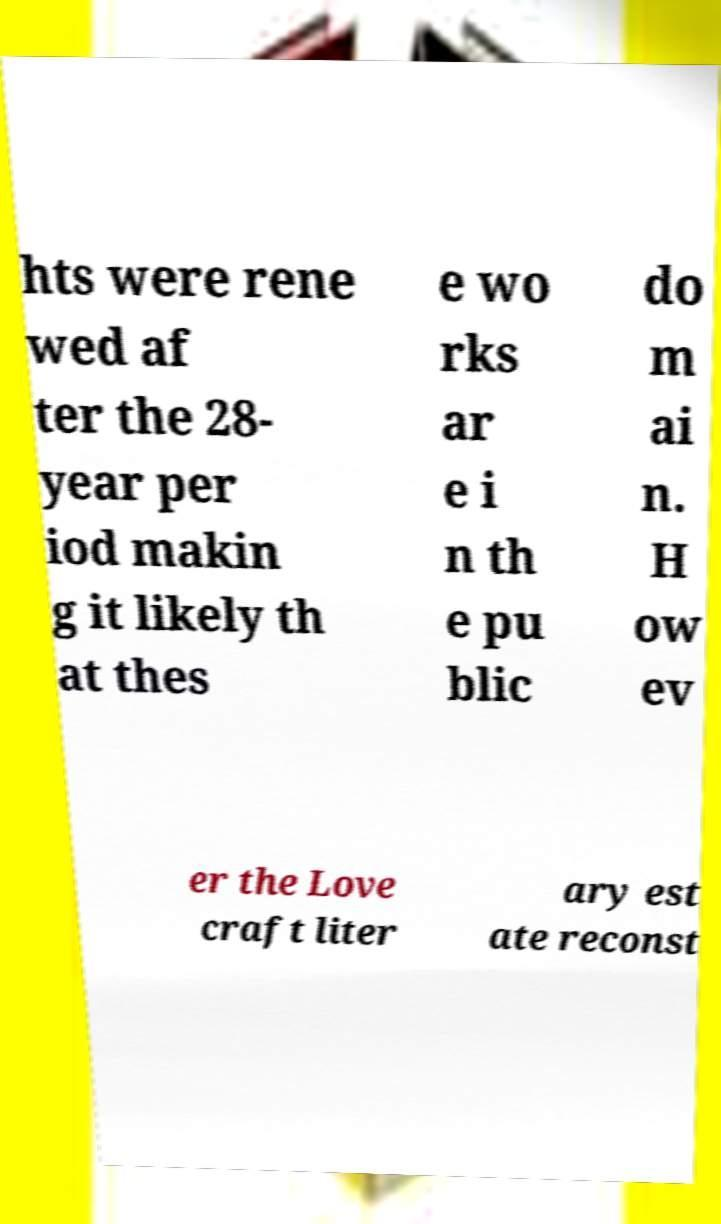Can you accurately transcribe the text from the provided image for me? hts were rene wed af ter the 28- year per iod makin g it likely th at thes e wo rks ar e i n th e pu blic do m ai n. H ow ev er the Love craft liter ary est ate reconst 